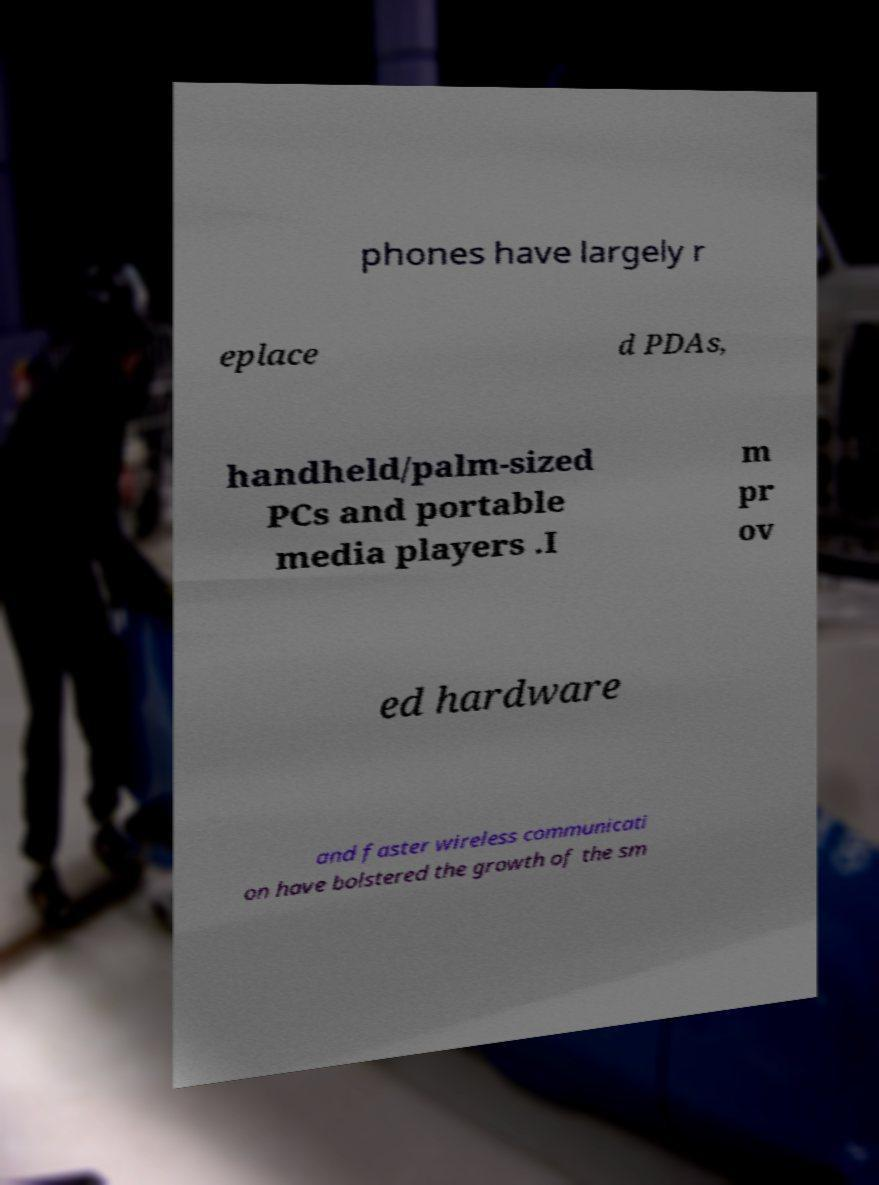Please identify and transcribe the text found in this image. phones have largely r eplace d PDAs, handheld/palm-sized PCs and portable media players .I m pr ov ed hardware and faster wireless communicati on have bolstered the growth of the sm 